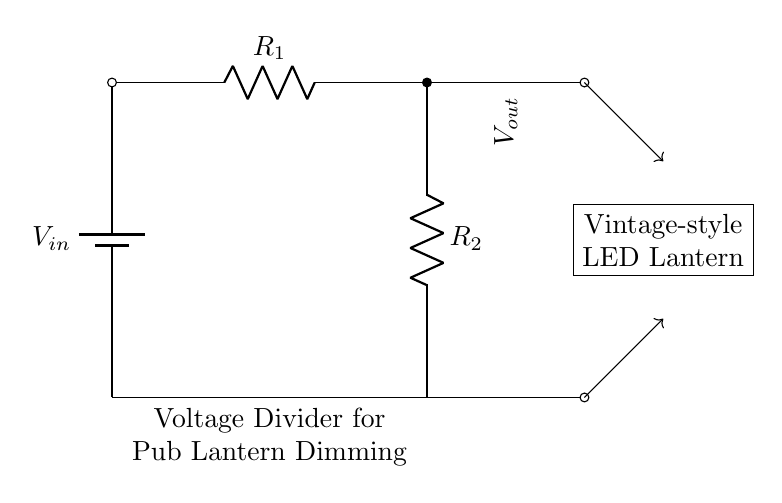What type of circuit is shown? The circuit is a voltage divider, which consists of two resistors connected in series, allowing for an output voltage that is a fraction of the input voltage.
Answer: Voltage divider What are the components used in the circuit? The circuit consists of a battery, two resistors, and a vintage-style LED lantern. The battery provides the input voltage, and the resistors control the output voltage.
Answer: Battery, resistors, LED lantern What is the purpose of the voltage divider in this circuit? The purpose of the voltage divider is to reduce the input voltage from the battery to a lower voltage that is suitable for the vintage-style LED lantern, which allows for dimming.
Answer: Dimming How many resistors are used in the voltage divider? There are two resistors in the voltage divider configuration. They are labeled as R1 and R2 in the circuit diagram.
Answer: Two What does Vout represent in the circuit? Vout represents the output voltage across the second resistor (R2) and is the voltage that powers the LED lantern; it is lower than the input voltage V in.
Answer: Output voltage If R1 is twice the value of R2, what would be the ratio of Vout to Vin? The ratio of Vout to Vin can be calculated using the voltage divider formula, which states Vout = Vin * (R2 / (R1 + R2)). If R1 = 2R2, then the ratio becomes 1/3.
Answer: One-third What happens to the output voltage if R2 is increased? If R2 is increased while R1 remains constant, the output voltage Vout will increase, as it depends directly on the value of R2 in the voltage divider formula.
Answer: Increases 